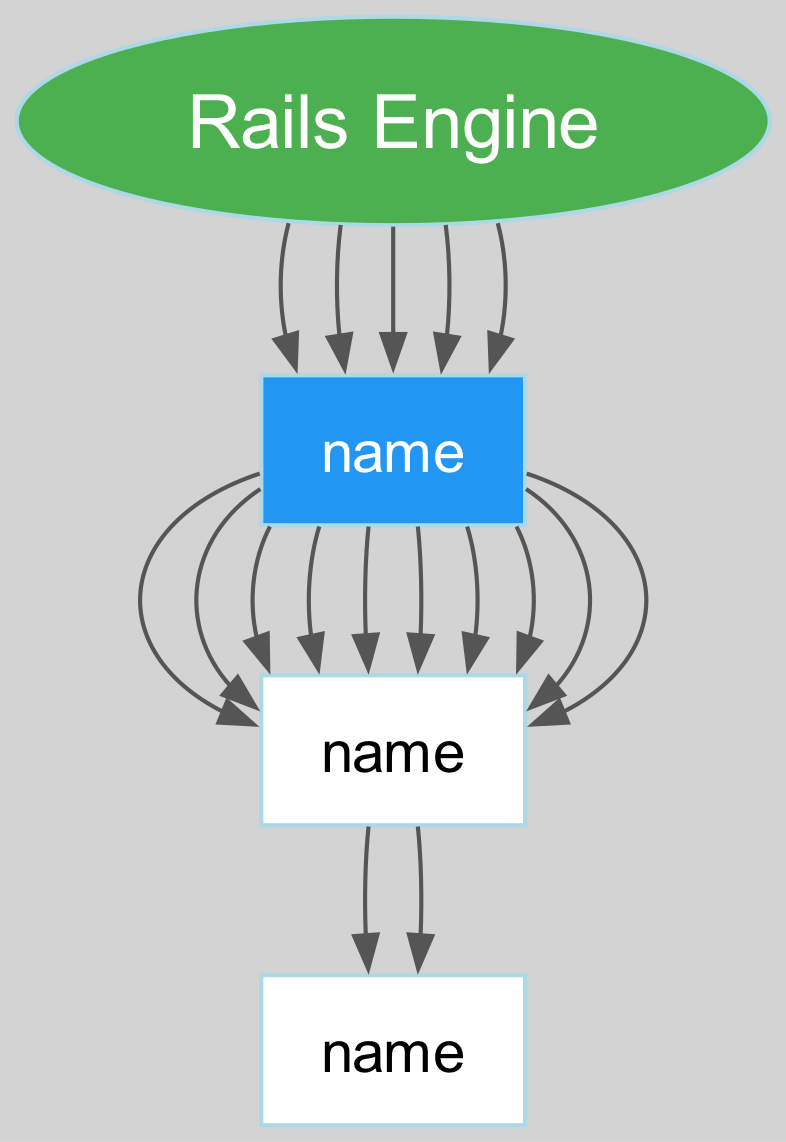What are the main components of the Rails Engine architecture? The main components are Routes, Controllers, Models, Views, and Configuration. These are the highest-level categories depicted in the diagram.
Answer: Routes, Controllers, Models, Views, Configuration How many children does the Routes node have? The Routes node splits into two children: Engine-specific routes and Main app routes integration. Therefore, it has two children.
Answer: 2 What routes are included under Engine-specific routes? Engine-specific routes include Mountable routes and Isolated namespace. These are the two specific routes listed under that category.
Answer: Mountable routes, Isolated namespace Which node inherits functionality from the Main app? The Controllers node has a child labeled Main app controllers inheritance, indicating that this component inherits functionality from the main application.
Answer: Main app controllers inheritance What is the relationship between Engine models and Shared database connections? Engine models and Shared database connections are siblings under the Models node, indicating they are both categories related to the model component of Rails Engine architecture.
Answer: Siblings How many total children does the Configuration node have? The Configuration node has two children: Initializers and Engine configuration options, thus totaling two children.
Answer: 2 Which view integration allows the Engine to use helpers from the main app? The Views node has a child called View helpers integration, indicating this integration allows the engine to access view helpers defined in the main application.
Answer: View helpers integration What are the components categories displayed at the top level of the diagram? The top-level categories are Routes, Controllers, Models, Views, and Configuration; these represent the main architectural components of a Rails engine.
Answer: Routes, Controllers, Models, Views, Configuration How many edges are there connecting child nodes under Controllers? Under the Controllers node, there are two edges connecting the Engine controllers and Main app controllers inheritance, thus there are two edges.
Answer: 2 